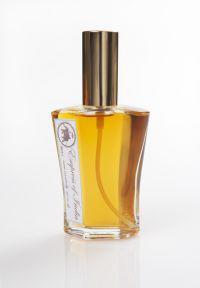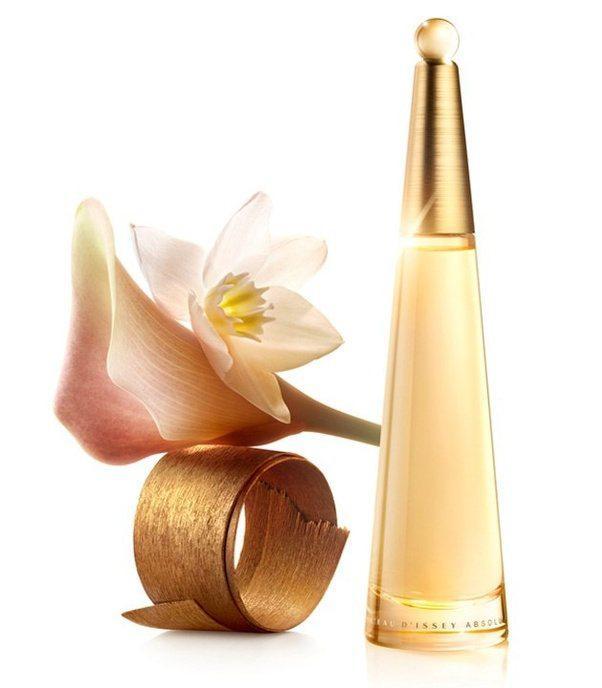The first image is the image on the left, the second image is the image on the right. For the images shown, is this caption "Each image contains at least three different fragrance bottles." true? Answer yes or no. No. The first image is the image on the left, the second image is the image on the right. For the images shown, is this caption "A single vial of perfume is standing in each of the images." true? Answer yes or no. Yes. 